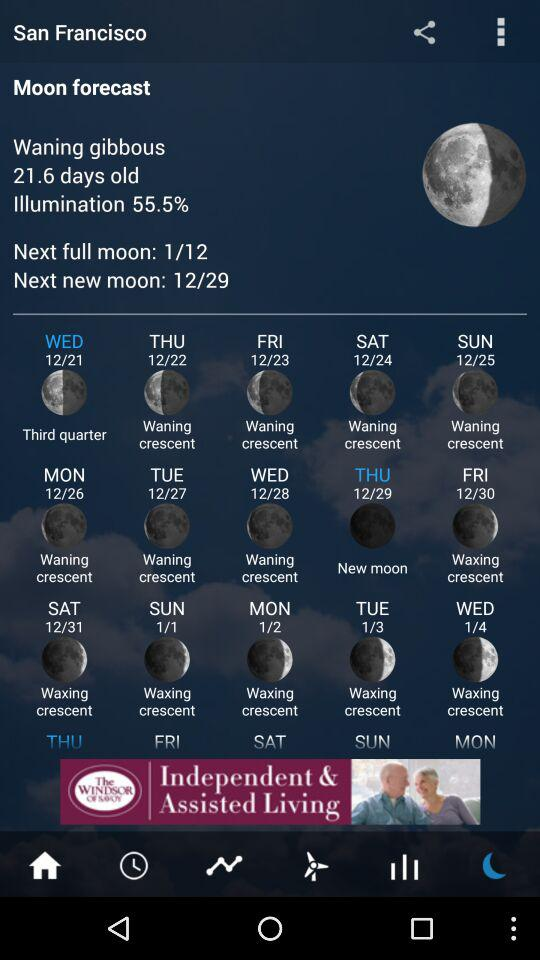How many days are there between the waning crescent moon on 12/24 and the waxing crescent moon on 1/4? 10 